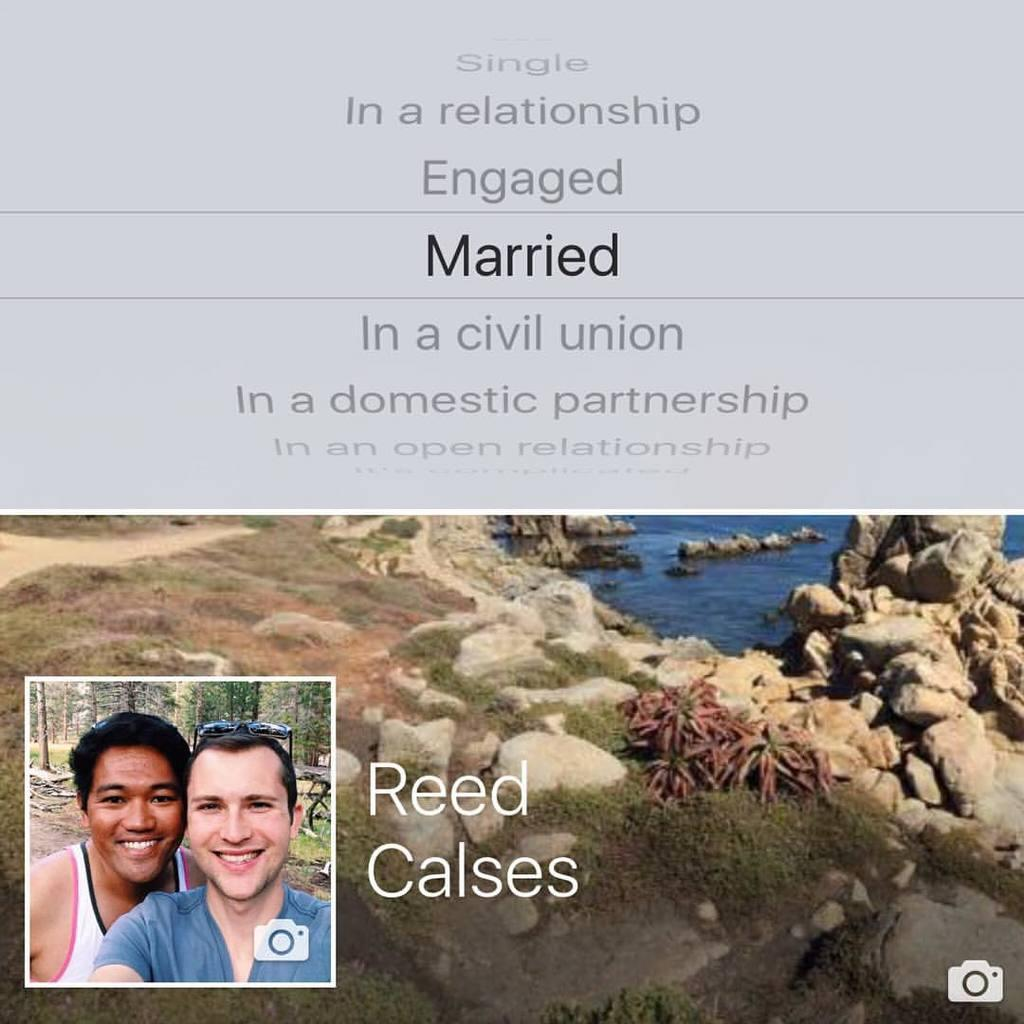How many people are present in the image? There are two persons in the image. What type of natural feature is visible in the image? There is a sea in the image. What other geological feature can be seen in the image? There are rocks in the image. What type of record is being played by the grandfather in the image? There is no grandfather or record present in the image. What type of insect can be seen crawling on the rocks in the image? There are no insects visible in the image; only rocks and a sea can be seen. 